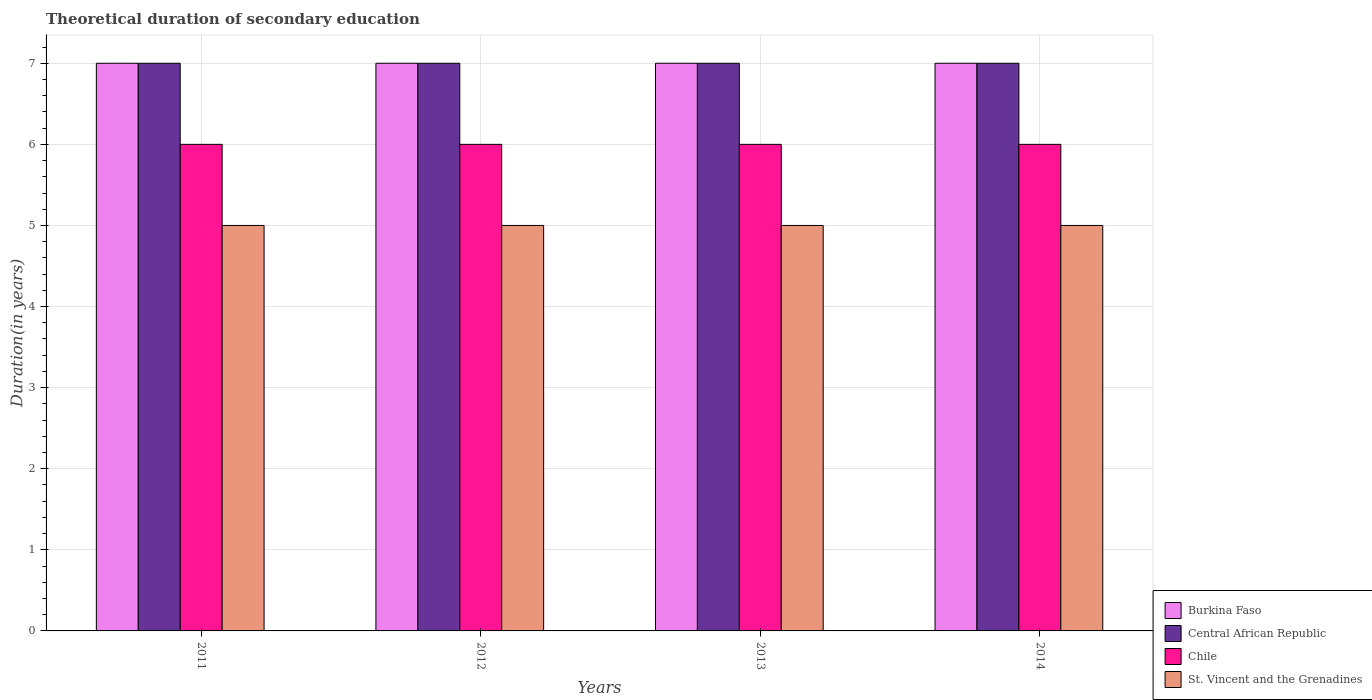How many different coloured bars are there?
Keep it short and to the point. 4. What is the total theoretical duration of secondary education in St. Vincent and the Grenadines in 2011?
Make the answer very short. 5. Across all years, what is the maximum total theoretical duration of secondary education in Central African Republic?
Your answer should be compact. 7. What is the total total theoretical duration of secondary education in Central African Republic in the graph?
Ensure brevity in your answer.  28. What is the difference between the total theoretical duration of secondary education in Burkina Faso in 2014 and the total theoretical duration of secondary education in Chile in 2013?
Your answer should be very brief. 1. In the year 2014, what is the difference between the total theoretical duration of secondary education in St. Vincent and the Grenadines and total theoretical duration of secondary education in Burkina Faso?
Give a very brief answer. -2. In how many years, is the total theoretical duration of secondary education in St. Vincent and the Grenadines greater than 1.2 years?
Ensure brevity in your answer.  4. What is the ratio of the total theoretical duration of secondary education in St. Vincent and the Grenadines in 2011 to that in 2014?
Give a very brief answer. 1. Is the total theoretical duration of secondary education in St. Vincent and the Grenadines in 2012 less than that in 2013?
Provide a short and direct response. No. What is the difference between the highest and the second highest total theoretical duration of secondary education in Chile?
Make the answer very short. 0. In how many years, is the total theoretical duration of secondary education in Central African Republic greater than the average total theoretical duration of secondary education in Central African Republic taken over all years?
Your answer should be compact. 0. Is it the case that in every year, the sum of the total theoretical duration of secondary education in Burkina Faso and total theoretical duration of secondary education in Central African Republic is greater than the sum of total theoretical duration of secondary education in St. Vincent and the Grenadines and total theoretical duration of secondary education in Chile?
Your answer should be compact. No. What does the 4th bar from the left in 2014 represents?
Provide a short and direct response. St. Vincent and the Grenadines. What does the 3rd bar from the right in 2012 represents?
Ensure brevity in your answer.  Central African Republic. Is it the case that in every year, the sum of the total theoretical duration of secondary education in Chile and total theoretical duration of secondary education in Central African Republic is greater than the total theoretical duration of secondary education in St. Vincent and the Grenadines?
Your answer should be compact. Yes. How many bars are there?
Ensure brevity in your answer.  16. How many years are there in the graph?
Keep it short and to the point. 4. Does the graph contain grids?
Offer a terse response. Yes. How are the legend labels stacked?
Provide a short and direct response. Vertical. What is the title of the graph?
Offer a very short reply. Theoretical duration of secondary education. Does "Least developed countries" appear as one of the legend labels in the graph?
Provide a succinct answer. No. What is the label or title of the Y-axis?
Provide a short and direct response. Duration(in years). What is the Duration(in years) of St. Vincent and the Grenadines in 2011?
Your answer should be compact. 5. What is the Duration(in years) of Burkina Faso in 2012?
Your response must be concise. 7. What is the Duration(in years) of Central African Republic in 2012?
Keep it short and to the point. 7. What is the Duration(in years) in Chile in 2012?
Give a very brief answer. 6. What is the Duration(in years) of Central African Republic in 2013?
Provide a succinct answer. 7. What is the Duration(in years) of Chile in 2013?
Offer a very short reply. 6. What is the Duration(in years) of Burkina Faso in 2014?
Offer a very short reply. 7. What is the Duration(in years) in Chile in 2014?
Make the answer very short. 6. What is the Duration(in years) in St. Vincent and the Grenadines in 2014?
Give a very brief answer. 5. Across all years, what is the maximum Duration(in years) of Central African Republic?
Provide a short and direct response. 7. Across all years, what is the maximum Duration(in years) in St. Vincent and the Grenadines?
Your answer should be very brief. 5. Across all years, what is the minimum Duration(in years) of Chile?
Your answer should be compact. 6. Across all years, what is the minimum Duration(in years) of St. Vincent and the Grenadines?
Make the answer very short. 5. What is the total Duration(in years) of Burkina Faso in the graph?
Provide a succinct answer. 28. What is the total Duration(in years) in Chile in the graph?
Provide a succinct answer. 24. What is the difference between the Duration(in years) in Burkina Faso in 2011 and that in 2012?
Your response must be concise. 0. What is the difference between the Duration(in years) in Central African Republic in 2011 and that in 2012?
Provide a short and direct response. 0. What is the difference between the Duration(in years) in Chile in 2011 and that in 2012?
Make the answer very short. 0. What is the difference between the Duration(in years) of St. Vincent and the Grenadines in 2011 and that in 2013?
Your answer should be very brief. 0. What is the difference between the Duration(in years) of Burkina Faso in 2011 and that in 2014?
Provide a succinct answer. 0. What is the difference between the Duration(in years) in Chile in 2011 and that in 2014?
Offer a very short reply. 0. What is the difference between the Duration(in years) of Chile in 2012 and that in 2013?
Offer a terse response. 0. What is the difference between the Duration(in years) of St. Vincent and the Grenadines in 2012 and that in 2013?
Give a very brief answer. 0. What is the difference between the Duration(in years) in Chile in 2012 and that in 2014?
Offer a very short reply. 0. What is the difference between the Duration(in years) in Burkina Faso in 2013 and that in 2014?
Provide a succinct answer. 0. What is the difference between the Duration(in years) in Chile in 2013 and that in 2014?
Offer a terse response. 0. What is the difference between the Duration(in years) in St. Vincent and the Grenadines in 2013 and that in 2014?
Your answer should be compact. 0. What is the difference between the Duration(in years) of Burkina Faso in 2011 and the Duration(in years) of Central African Republic in 2012?
Your response must be concise. 0. What is the difference between the Duration(in years) in Burkina Faso in 2011 and the Duration(in years) in St. Vincent and the Grenadines in 2012?
Keep it short and to the point. 2. What is the difference between the Duration(in years) of Central African Republic in 2011 and the Duration(in years) of Chile in 2012?
Make the answer very short. 1. What is the difference between the Duration(in years) of Burkina Faso in 2011 and the Duration(in years) of Central African Republic in 2013?
Keep it short and to the point. 0. What is the difference between the Duration(in years) of Burkina Faso in 2011 and the Duration(in years) of St. Vincent and the Grenadines in 2013?
Make the answer very short. 2. What is the difference between the Duration(in years) of Chile in 2011 and the Duration(in years) of St. Vincent and the Grenadines in 2013?
Offer a very short reply. 1. What is the difference between the Duration(in years) in Burkina Faso in 2011 and the Duration(in years) in Central African Republic in 2014?
Provide a short and direct response. 0. What is the difference between the Duration(in years) of Burkina Faso in 2011 and the Duration(in years) of Chile in 2014?
Make the answer very short. 1. What is the difference between the Duration(in years) in Central African Republic in 2011 and the Duration(in years) in Chile in 2014?
Offer a very short reply. 1. What is the difference between the Duration(in years) of Burkina Faso in 2012 and the Duration(in years) of Central African Republic in 2013?
Your answer should be very brief. 0. What is the difference between the Duration(in years) in Central African Republic in 2012 and the Duration(in years) in Chile in 2013?
Your answer should be very brief. 1. What is the difference between the Duration(in years) of Central African Republic in 2012 and the Duration(in years) of St. Vincent and the Grenadines in 2014?
Your answer should be compact. 2. What is the difference between the Duration(in years) of Chile in 2012 and the Duration(in years) of St. Vincent and the Grenadines in 2014?
Give a very brief answer. 1. What is the difference between the Duration(in years) in Central African Republic in 2013 and the Duration(in years) in St. Vincent and the Grenadines in 2014?
Ensure brevity in your answer.  2. What is the average Duration(in years) in Central African Republic per year?
Your answer should be compact. 7. In the year 2011, what is the difference between the Duration(in years) of Burkina Faso and Duration(in years) of St. Vincent and the Grenadines?
Ensure brevity in your answer.  2. In the year 2012, what is the difference between the Duration(in years) of Burkina Faso and Duration(in years) of Central African Republic?
Offer a terse response. 0. In the year 2012, what is the difference between the Duration(in years) of Burkina Faso and Duration(in years) of St. Vincent and the Grenadines?
Your answer should be very brief. 2. In the year 2012, what is the difference between the Duration(in years) in Central African Republic and Duration(in years) in Chile?
Your response must be concise. 1. In the year 2012, what is the difference between the Duration(in years) of Chile and Duration(in years) of St. Vincent and the Grenadines?
Give a very brief answer. 1. In the year 2013, what is the difference between the Duration(in years) of Burkina Faso and Duration(in years) of St. Vincent and the Grenadines?
Provide a succinct answer. 2. In the year 2013, what is the difference between the Duration(in years) in Central African Republic and Duration(in years) in Chile?
Offer a very short reply. 1. In the year 2014, what is the difference between the Duration(in years) of Burkina Faso and Duration(in years) of Central African Republic?
Keep it short and to the point. 0. In the year 2014, what is the difference between the Duration(in years) in Burkina Faso and Duration(in years) in St. Vincent and the Grenadines?
Keep it short and to the point. 2. In the year 2014, what is the difference between the Duration(in years) of Central African Republic and Duration(in years) of St. Vincent and the Grenadines?
Ensure brevity in your answer.  2. What is the ratio of the Duration(in years) of Central African Republic in 2011 to that in 2012?
Ensure brevity in your answer.  1. What is the ratio of the Duration(in years) in Burkina Faso in 2011 to that in 2013?
Your answer should be very brief. 1. What is the ratio of the Duration(in years) of Central African Republic in 2011 to that in 2013?
Provide a short and direct response. 1. What is the ratio of the Duration(in years) in Chile in 2011 to that in 2013?
Your answer should be compact. 1. What is the ratio of the Duration(in years) in St. Vincent and the Grenadines in 2011 to that in 2013?
Ensure brevity in your answer.  1. What is the ratio of the Duration(in years) in Chile in 2011 to that in 2014?
Provide a short and direct response. 1. What is the ratio of the Duration(in years) of St. Vincent and the Grenadines in 2012 to that in 2013?
Make the answer very short. 1. What is the ratio of the Duration(in years) of Central African Republic in 2012 to that in 2014?
Offer a very short reply. 1. What is the ratio of the Duration(in years) in Chile in 2012 to that in 2014?
Your answer should be very brief. 1. What is the ratio of the Duration(in years) in St. Vincent and the Grenadines in 2012 to that in 2014?
Provide a short and direct response. 1. What is the ratio of the Duration(in years) in Burkina Faso in 2013 to that in 2014?
Provide a short and direct response. 1. What is the ratio of the Duration(in years) of Central African Republic in 2013 to that in 2014?
Offer a terse response. 1. What is the ratio of the Duration(in years) of Chile in 2013 to that in 2014?
Your response must be concise. 1. What is the difference between the highest and the second highest Duration(in years) of Chile?
Make the answer very short. 0. What is the difference between the highest and the second highest Duration(in years) of St. Vincent and the Grenadines?
Your answer should be very brief. 0. What is the difference between the highest and the lowest Duration(in years) in Burkina Faso?
Make the answer very short. 0. What is the difference between the highest and the lowest Duration(in years) in St. Vincent and the Grenadines?
Provide a succinct answer. 0. 